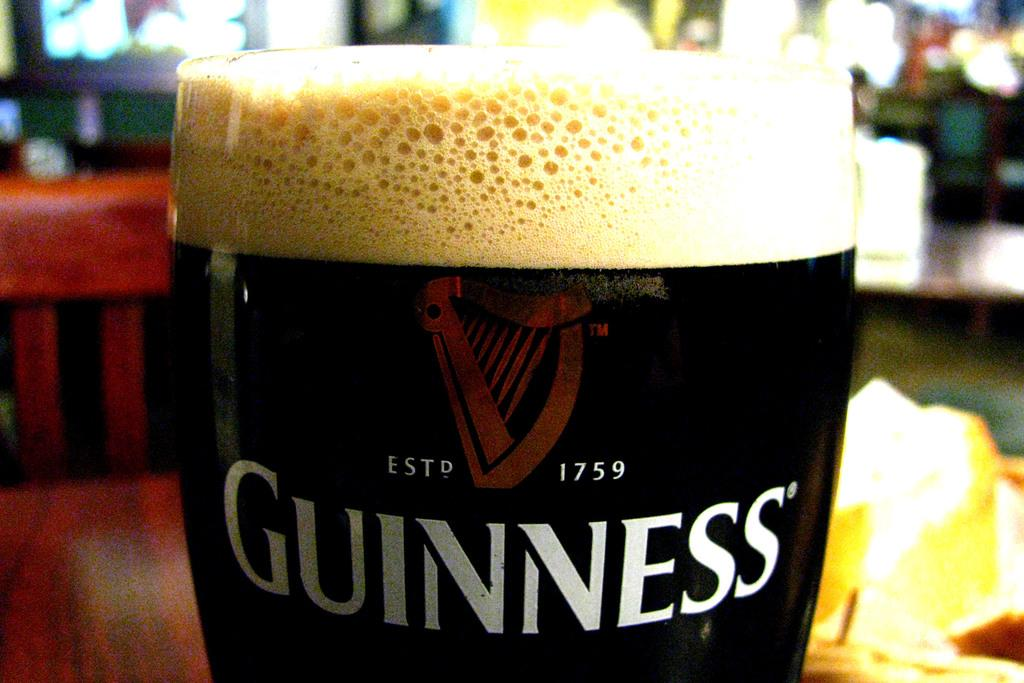<image>
Provide a brief description of the given image. A full glass of Guinness on a table 